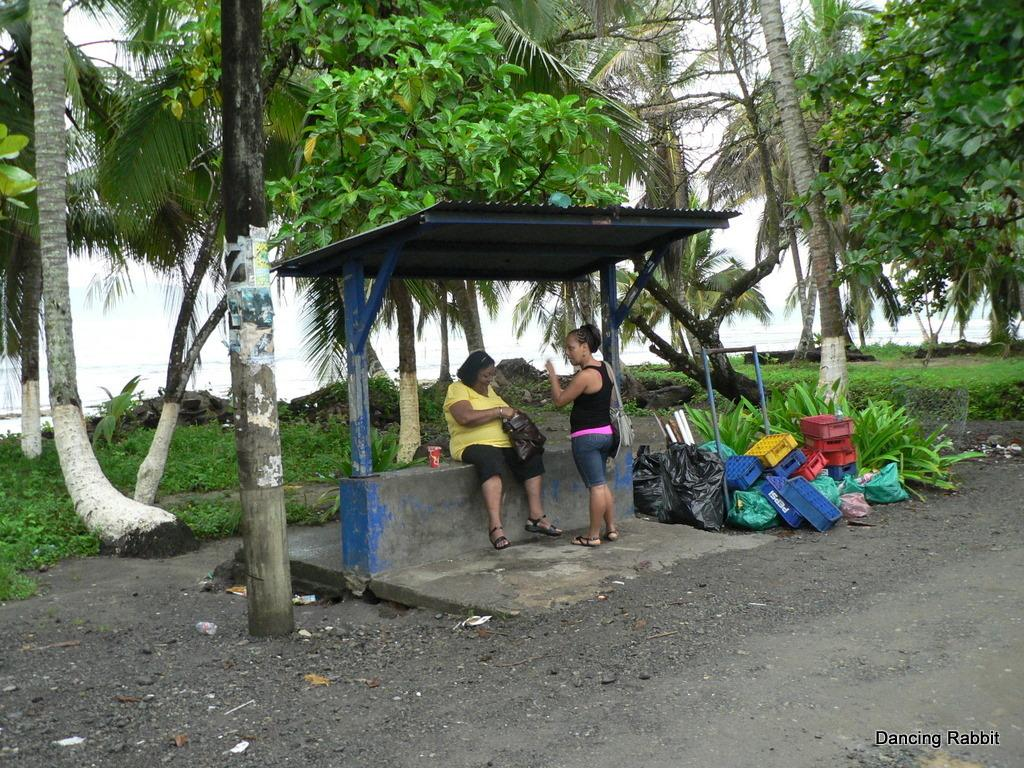What type of vegetation can be seen in the image? There are trees, plants, and grass visible in the image. What type of objects are present in the image? There are covers and glass visible in the image. How many people are in the image? There are two people in the image. What is visible in the background of the image? There is sky and water visible in the image. Can you tell me how many beads are on the wheel in the image? There is no wheel or beads present in the image. What type of cork is used to seal the glass in the image? There is no cork visible in the image, as it only shows glass without any indication of being sealed. 